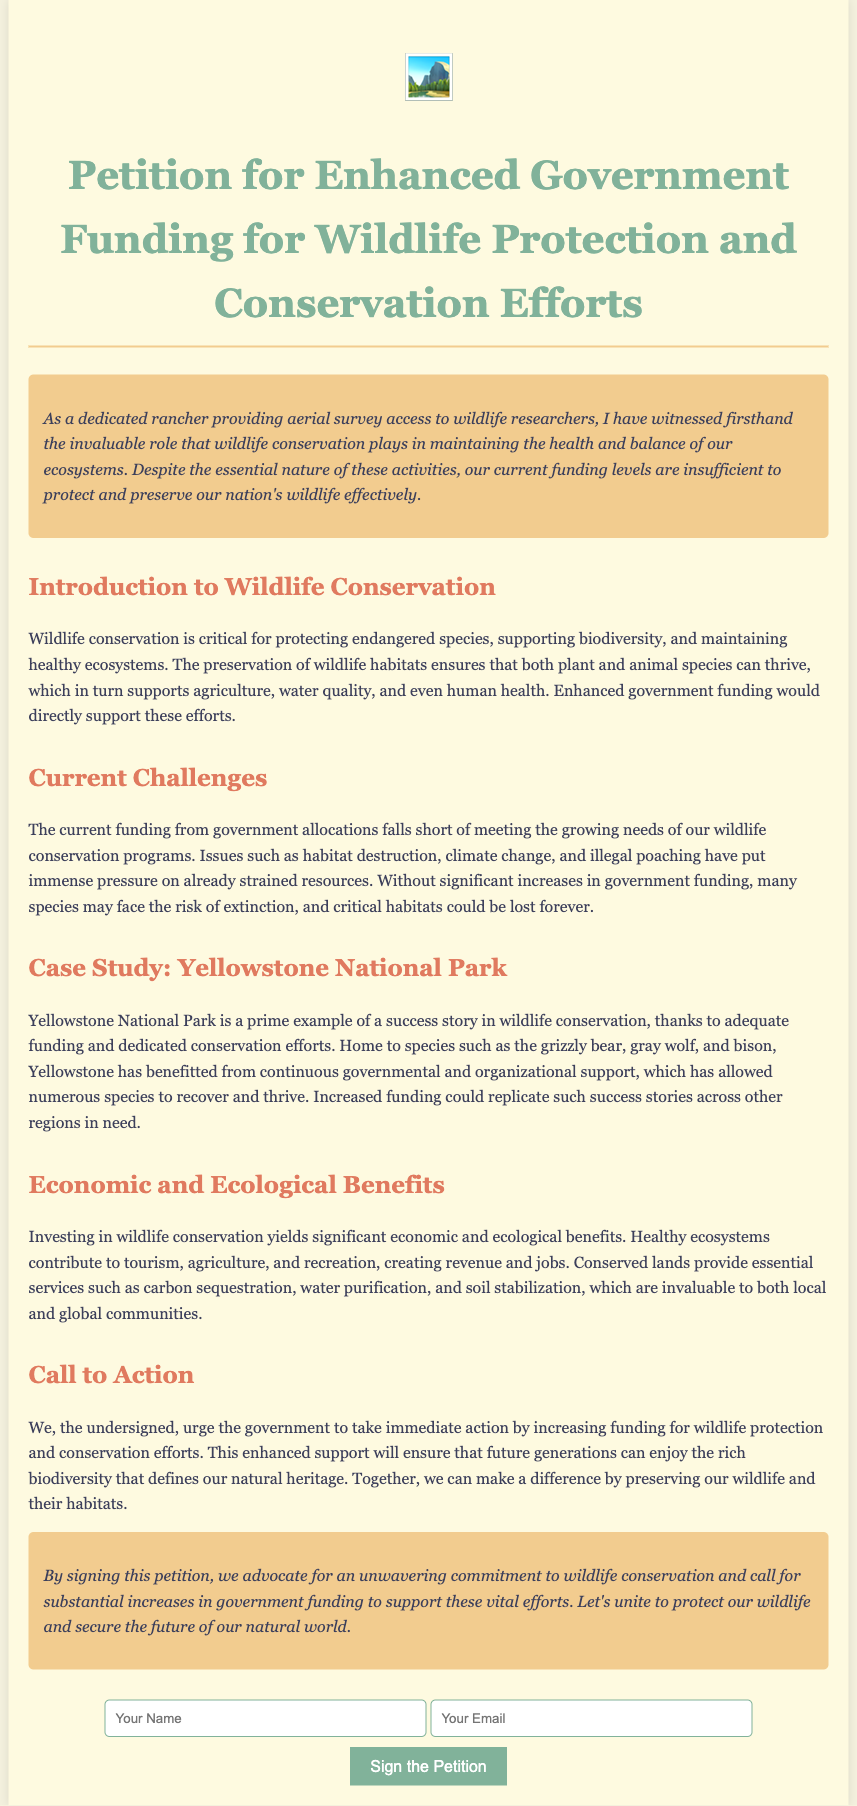What is the title of the document? The title is clearly stated at the top of the document as "Petition for Enhanced Government Funding for Wildlife Protection and Conservation Efforts."
Answer: Petition for Enhanced Government Funding for Wildlife Protection and Conservation Efforts What role does the rancher provide for wildlife researchers? The document mentions that the rancher provides "aerial survey access" to wildlife researchers.
Answer: aerial survey access What are some challenges mentioned in the document? The document lists challenges such as "habitat destruction," "climate change," and "illegal poaching."
Answer: habitat destruction, climate change, illegal poaching What is a success story mentioned in the petition? Yellowstone National Park is highlighted in the document as a success story of wildlife conservation due to adequate funding.
Answer: Yellowstone National Park What benefits are derived from investing in wildlife conservation? The document states that investing in wildlife conservation yields "significant economic and ecological benefits."
Answer: significant economic and ecological benefits What action does the petition urge the government to take? The petition calls for the government to "take immediate action by increasing funding for wildlife protection and conservation efforts."
Answer: increasing funding for wildlife protection and conservation efforts How does the document conclude regarding wildlife conservation? The conclusion emphasizes the importance of an "unwavering commitment to wildlife conservation" and increased funding.
Answer: unwavering commitment to wildlife conservation What type of icon is displayed in the beginning? The document contains a ranch-related icon: "🏞️".
Answer: 🏞️ 